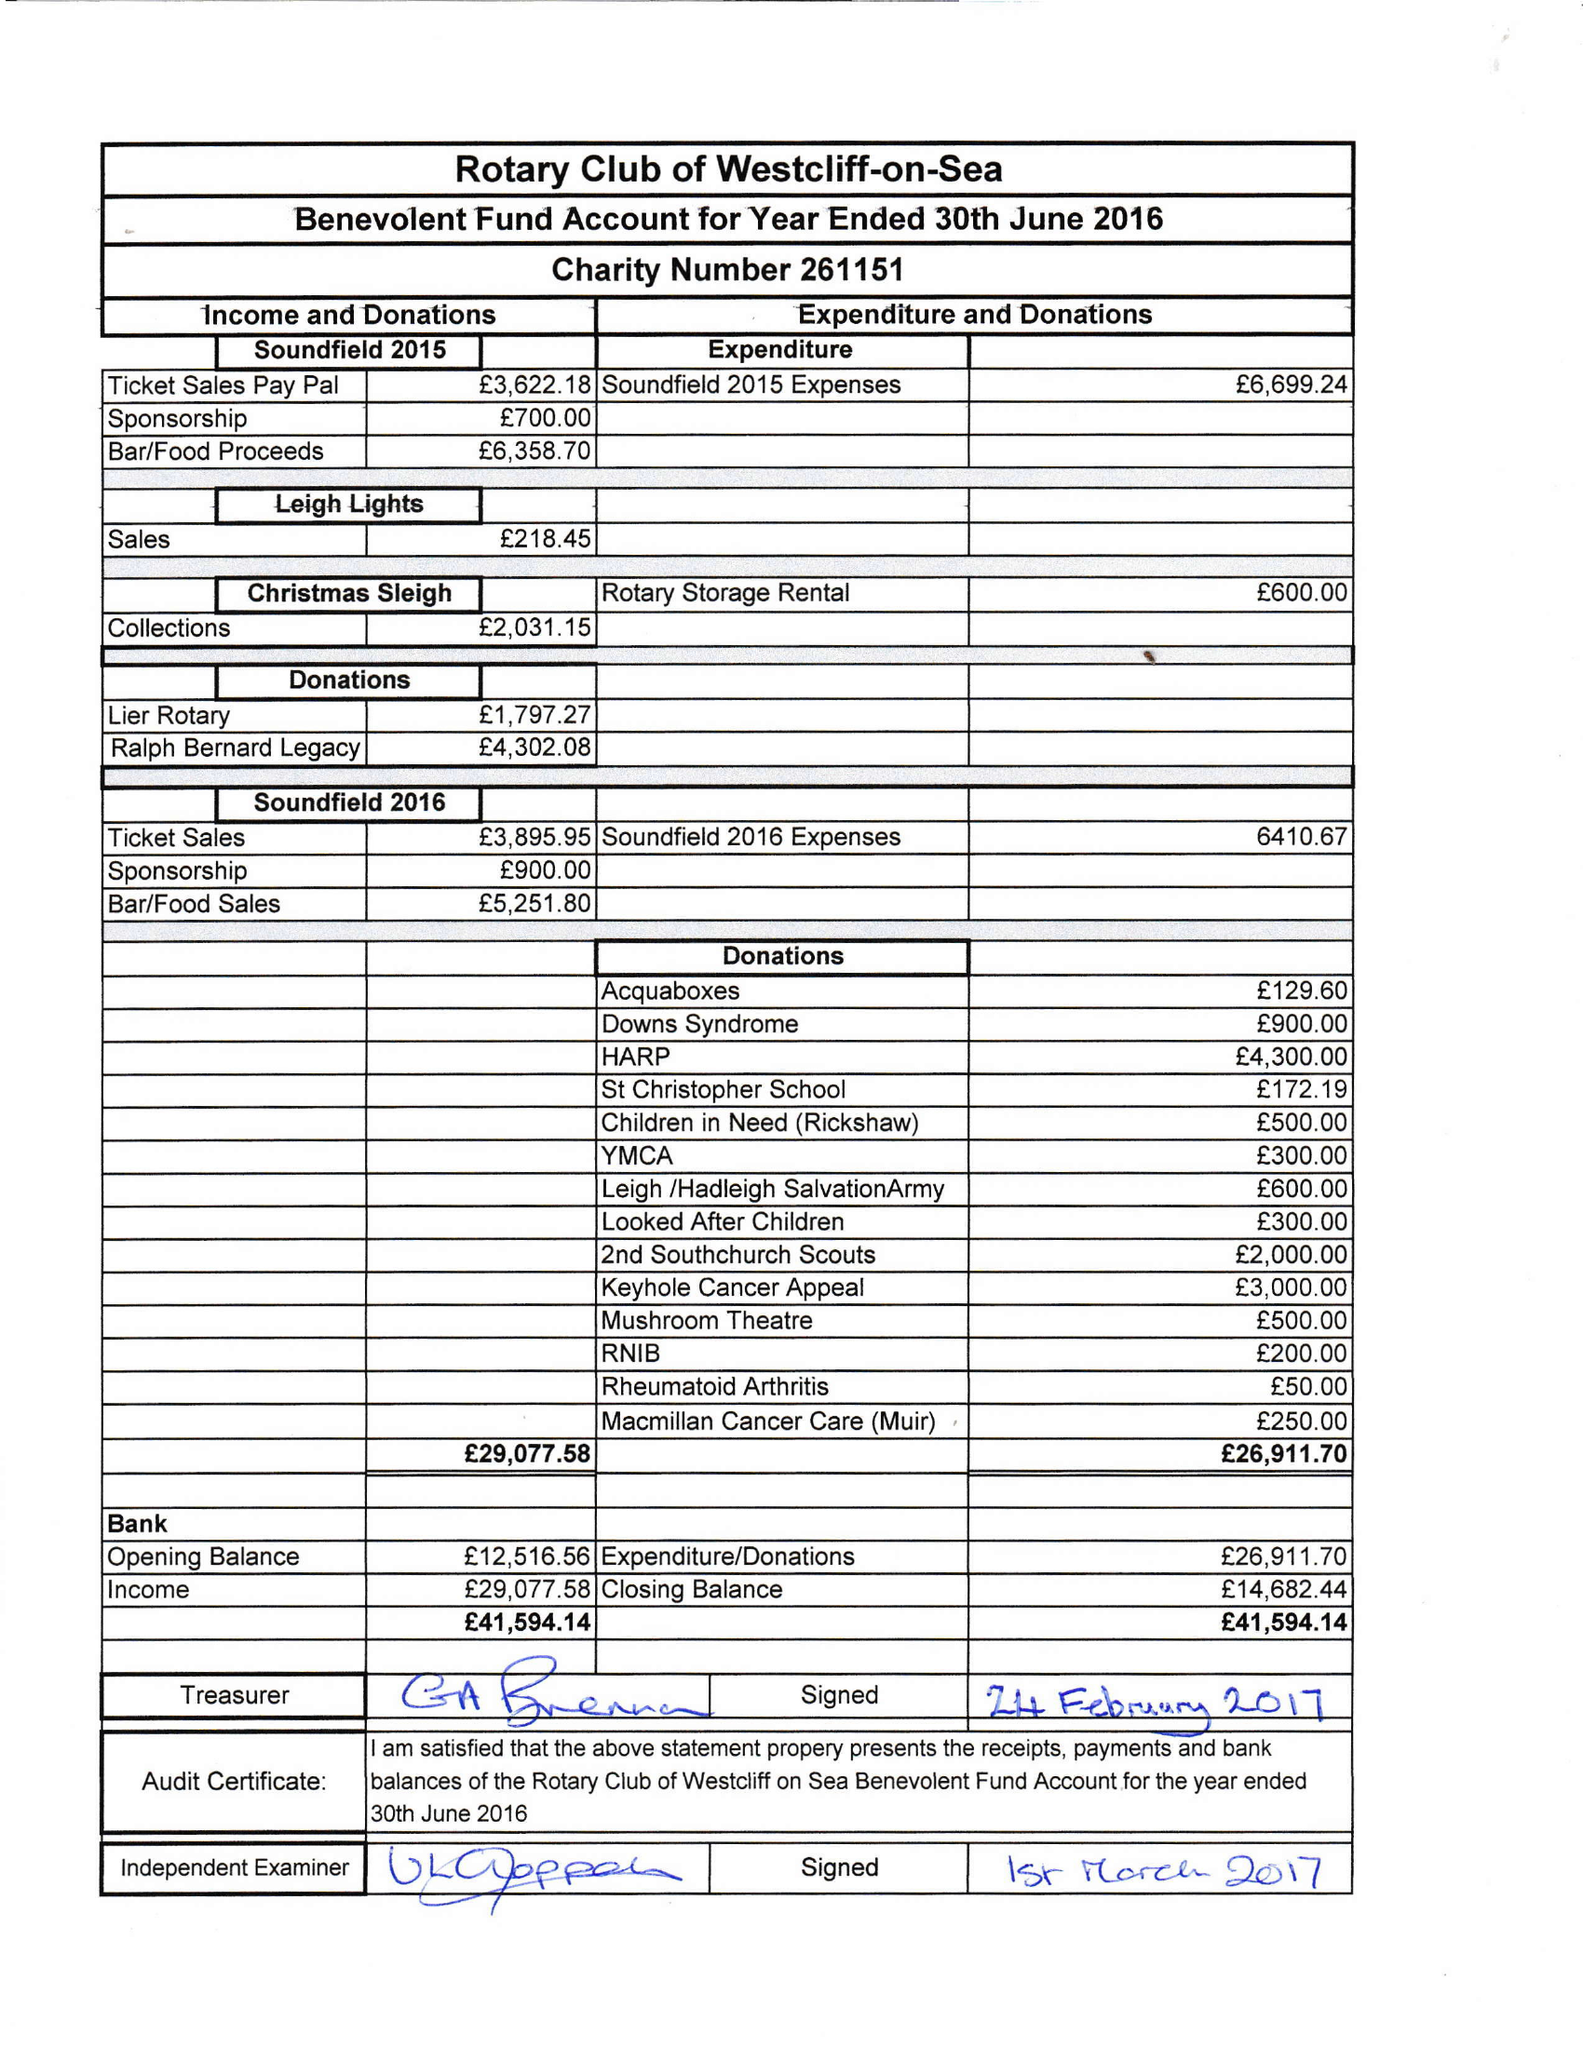What is the value for the address__post_town?
Answer the question using a single word or phrase. WESTCLIFF-ON-SEA 